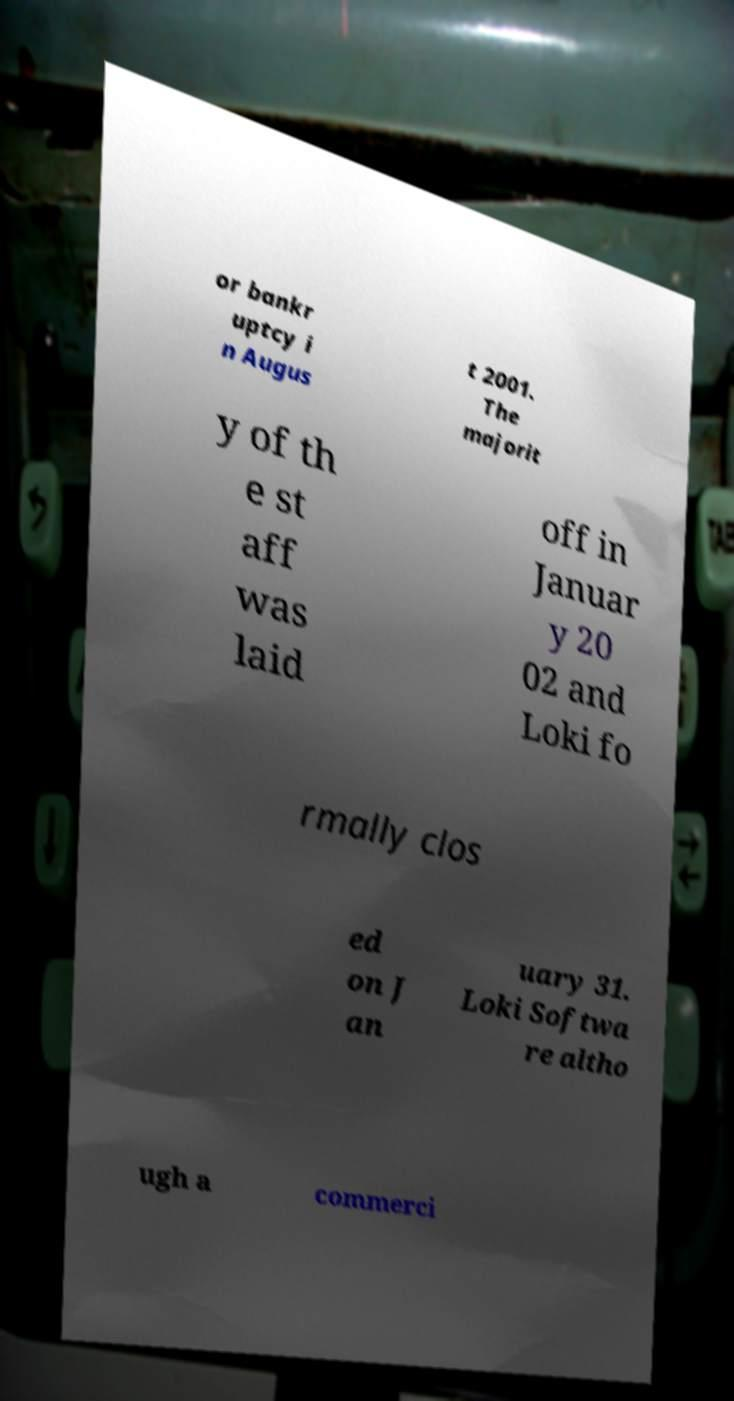Please read and relay the text visible in this image. What does it say? or bankr uptcy i n Augus t 2001. The majorit y of th e st aff was laid off in Januar y 20 02 and Loki fo rmally clos ed on J an uary 31. Loki Softwa re altho ugh a commerci 